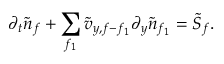Convert formula to latex. <formula><loc_0><loc_0><loc_500><loc_500>\partial _ { t } \tilde { n } _ { f } + \sum _ { f _ { 1 } } \tilde { v } _ { y , f - f _ { 1 } } \partial _ { y } \tilde { n } _ { f _ { 1 } } = \tilde { S } _ { f } .</formula> 